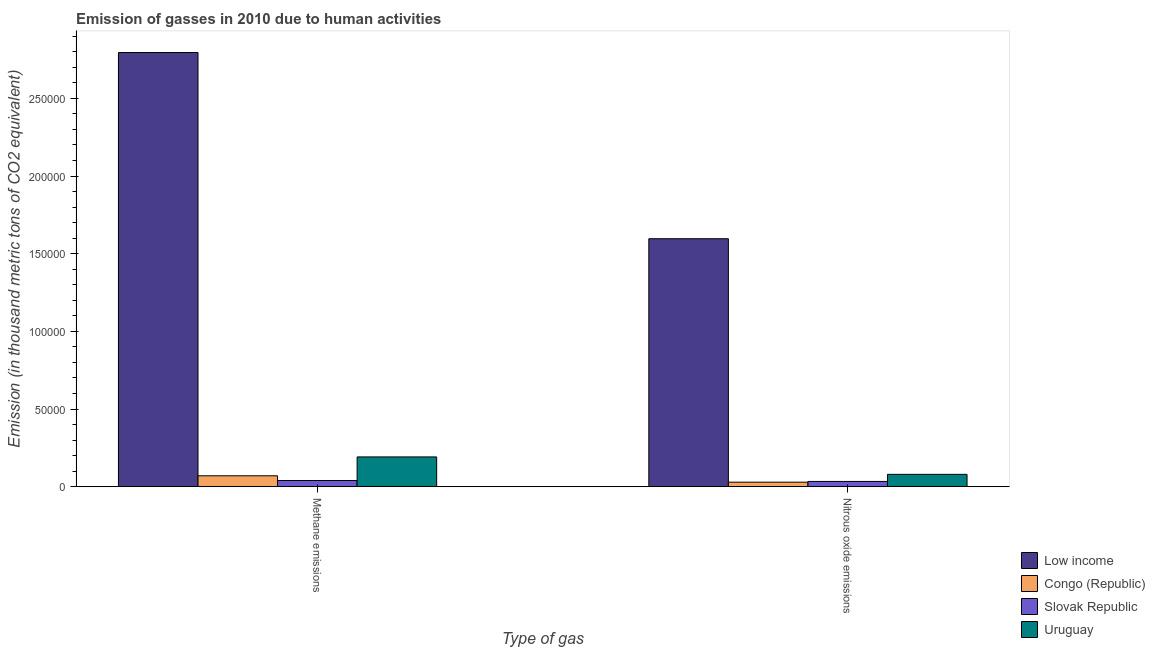How many different coloured bars are there?
Offer a terse response. 4. How many groups of bars are there?
Make the answer very short. 2. Are the number of bars per tick equal to the number of legend labels?
Your response must be concise. Yes. Are the number of bars on each tick of the X-axis equal?
Ensure brevity in your answer.  Yes. How many bars are there on the 2nd tick from the right?
Your answer should be very brief. 4. What is the label of the 2nd group of bars from the left?
Give a very brief answer. Nitrous oxide emissions. What is the amount of nitrous oxide emissions in Slovak Republic?
Offer a terse response. 3380.2. Across all countries, what is the maximum amount of methane emissions?
Your answer should be very brief. 2.79e+05. Across all countries, what is the minimum amount of nitrous oxide emissions?
Ensure brevity in your answer.  2899.8. In which country was the amount of methane emissions maximum?
Give a very brief answer. Low income. In which country was the amount of nitrous oxide emissions minimum?
Ensure brevity in your answer.  Congo (Republic). What is the total amount of nitrous oxide emissions in the graph?
Provide a short and direct response. 1.74e+05. What is the difference between the amount of methane emissions in Congo (Republic) and that in Uruguay?
Provide a short and direct response. -1.21e+04. What is the difference between the amount of nitrous oxide emissions in Uruguay and the amount of methane emissions in Slovak Republic?
Provide a succinct answer. 3961.8. What is the average amount of methane emissions per country?
Offer a terse response. 7.74e+04. What is the difference between the amount of nitrous oxide emissions and amount of methane emissions in Congo (Republic)?
Make the answer very short. -4116.2. In how many countries, is the amount of nitrous oxide emissions greater than 140000 thousand metric tons?
Keep it short and to the point. 1. What is the ratio of the amount of nitrous oxide emissions in Low income to that in Slovak Republic?
Your answer should be very brief. 47.22. What does the 3rd bar from the left in Nitrous oxide emissions represents?
Give a very brief answer. Slovak Republic. What does the 2nd bar from the right in Nitrous oxide emissions represents?
Offer a very short reply. Slovak Republic. How many bars are there?
Provide a short and direct response. 8. Are all the bars in the graph horizontal?
Ensure brevity in your answer.  No. Are the values on the major ticks of Y-axis written in scientific E-notation?
Offer a terse response. No. Does the graph contain any zero values?
Your response must be concise. No. Does the graph contain grids?
Make the answer very short. No. Where does the legend appear in the graph?
Make the answer very short. Bottom right. How many legend labels are there?
Provide a short and direct response. 4. What is the title of the graph?
Give a very brief answer. Emission of gasses in 2010 due to human activities. What is the label or title of the X-axis?
Ensure brevity in your answer.  Type of gas. What is the label or title of the Y-axis?
Offer a very short reply. Emission (in thousand metric tons of CO2 equivalent). What is the Emission (in thousand metric tons of CO2 equivalent) of Low income in Methane emissions?
Offer a very short reply. 2.79e+05. What is the Emission (in thousand metric tons of CO2 equivalent) in Congo (Republic) in Methane emissions?
Ensure brevity in your answer.  7016. What is the Emission (in thousand metric tons of CO2 equivalent) of Slovak Republic in Methane emissions?
Make the answer very short. 3984.7. What is the Emission (in thousand metric tons of CO2 equivalent) of Uruguay in Methane emissions?
Offer a terse response. 1.92e+04. What is the Emission (in thousand metric tons of CO2 equivalent) in Low income in Nitrous oxide emissions?
Make the answer very short. 1.60e+05. What is the Emission (in thousand metric tons of CO2 equivalent) of Congo (Republic) in Nitrous oxide emissions?
Your response must be concise. 2899.8. What is the Emission (in thousand metric tons of CO2 equivalent) in Slovak Republic in Nitrous oxide emissions?
Give a very brief answer. 3380.2. What is the Emission (in thousand metric tons of CO2 equivalent) in Uruguay in Nitrous oxide emissions?
Make the answer very short. 7946.5. Across all Type of gas, what is the maximum Emission (in thousand metric tons of CO2 equivalent) in Low income?
Offer a terse response. 2.79e+05. Across all Type of gas, what is the maximum Emission (in thousand metric tons of CO2 equivalent) of Congo (Republic)?
Offer a terse response. 7016. Across all Type of gas, what is the maximum Emission (in thousand metric tons of CO2 equivalent) in Slovak Republic?
Give a very brief answer. 3984.7. Across all Type of gas, what is the maximum Emission (in thousand metric tons of CO2 equivalent) in Uruguay?
Make the answer very short. 1.92e+04. Across all Type of gas, what is the minimum Emission (in thousand metric tons of CO2 equivalent) of Low income?
Keep it short and to the point. 1.60e+05. Across all Type of gas, what is the minimum Emission (in thousand metric tons of CO2 equivalent) of Congo (Republic)?
Make the answer very short. 2899.8. Across all Type of gas, what is the minimum Emission (in thousand metric tons of CO2 equivalent) of Slovak Republic?
Your answer should be very brief. 3380.2. Across all Type of gas, what is the minimum Emission (in thousand metric tons of CO2 equivalent) in Uruguay?
Your answer should be compact. 7946.5. What is the total Emission (in thousand metric tons of CO2 equivalent) in Low income in the graph?
Your answer should be compact. 4.39e+05. What is the total Emission (in thousand metric tons of CO2 equivalent) of Congo (Republic) in the graph?
Offer a terse response. 9915.8. What is the total Emission (in thousand metric tons of CO2 equivalent) in Slovak Republic in the graph?
Provide a succinct answer. 7364.9. What is the total Emission (in thousand metric tons of CO2 equivalent) in Uruguay in the graph?
Provide a short and direct response. 2.71e+04. What is the difference between the Emission (in thousand metric tons of CO2 equivalent) of Low income in Methane emissions and that in Nitrous oxide emissions?
Make the answer very short. 1.20e+05. What is the difference between the Emission (in thousand metric tons of CO2 equivalent) in Congo (Republic) in Methane emissions and that in Nitrous oxide emissions?
Offer a terse response. 4116.2. What is the difference between the Emission (in thousand metric tons of CO2 equivalent) in Slovak Republic in Methane emissions and that in Nitrous oxide emissions?
Your answer should be very brief. 604.5. What is the difference between the Emission (in thousand metric tons of CO2 equivalent) of Uruguay in Methane emissions and that in Nitrous oxide emissions?
Offer a very short reply. 1.12e+04. What is the difference between the Emission (in thousand metric tons of CO2 equivalent) of Low income in Methane emissions and the Emission (in thousand metric tons of CO2 equivalent) of Congo (Republic) in Nitrous oxide emissions?
Give a very brief answer. 2.77e+05. What is the difference between the Emission (in thousand metric tons of CO2 equivalent) of Low income in Methane emissions and the Emission (in thousand metric tons of CO2 equivalent) of Slovak Republic in Nitrous oxide emissions?
Offer a terse response. 2.76e+05. What is the difference between the Emission (in thousand metric tons of CO2 equivalent) of Low income in Methane emissions and the Emission (in thousand metric tons of CO2 equivalent) of Uruguay in Nitrous oxide emissions?
Offer a terse response. 2.72e+05. What is the difference between the Emission (in thousand metric tons of CO2 equivalent) in Congo (Republic) in Methane emissions and the Emission (in thousand metric tons of CO2 equivalent) in Slovak Republic in Nitrous oxide emissions?
Provide a succinct answer. 3635.8. What is the difference between the Emission (in thousand metric tons of CO2 equivalent) in Congo (Republic) in Methane emissions and the Emission (in thousand metric tons of CO2 equivalent) in Uruguay in Nitrous oxide emissions?
Your answer should be compact. -930.5. What is the difference between the Emission (in thousand metric tons of CO2 equivalent) in Slovak Republic in Methane emissions and the Emission (in thousand metric tons of CO2 equivalent) in Uruguay in Nitrous oxide emissions?
Ensure brevity in your answer.  -3961.8. What is the average Emission (in thousand metric tons of CO2 equivalent) of Low income per Type of gas?
Your response must be concise. 2.20e+05. What is the average Emission (in thousand metric tons of CO2 equivalent) of Congo (Republic) per Type of gas?
Make the answer very short. 4957.9. What is the average Emission (in thousand metric tons of CO2 equivalent) in Slovak Republic per Type of gas?
Make the answer very short. 3682.45. What is the average Emission (in thousand metric tons of CO2 equivalent) in Uruguay per Type of gas?
Offer a very short reply. 1.36e+04. What is the difference between the Emission (in thousand metric tons of CO2 equivalent) in Low income and Emission (in thousand metric tons of CO2 equivalent) in Congo (Republic) in Methane emissions?
Your answer should be very brief. 2.72e+05. What is the difference between the Emission (in thousand metric tons of CO2 equivalent) of Low income and Emission (in thousand metric tons of CO2 equivalent) of Slovak Republic in Methane emissions?
Your answer should be very brief. 2.75e+05. What is the difference between the Emission (in thousand metric tons of CO2 equivalent) of Low income and Emission (in thousand metric tons of CO2 equivalent) of Uruguay in Methane emissions?
Provide a short and direct response. 2.60e+05. What is the difference between the Emission (in thousand metric tons of CO2 equivalent) in Congo (Republic) and Emission (in thousand metric tons of CO2 equivalent) in Slovak Republic in Methane emissions?
Make the answer very short. 3031.3. What is the difference between the Emission (in thousand metric tons of CO2 equivalent) in Congo (Republic) and Emission (in thousand metric tons of CO2 equivalent) in Uruguay in Methane emissions?
Ensure brevity in your answer.  -1.21e+04. What is the difference between the Emission (in thousand metric tons of CO2 equivalent) in Slovak Republic and Emission (in thousand metric tons of CO2 equivalent) in Uruguay in Methane emissions?
Offer a terse response. -1.52e+04. What is the difference between the Emission (in thousand metric tons of CO2 equivalent) in Low income and Emission (in thousand metric tons of CO2 equivalent) in Congo (Republic) in Nitrous oxide emissions?
Provide a succinct answer. 1.57e+05. What is the difference between the Emission (in thousand metric tons of CO2 equivalent) of Low income and Emission (in thousand metric tons of CO2 equivalent) of Slovak Republic in Nitrous oxide emissions?
Make the answer very short. 1.56e+05. What is the difference between the Emission (in thousand metric tons of CO2 equivalent) in Low income and Emission (in thousand metric tons of CO2 equivalent) in Uruguay in Nitrous oxide emissions?
Make the answer very short. 1.52e+05. What is the difference between the Emission (in thousand metric tons of CO2 equivalent) in Congo (Republic) and Emission (in thousand metric tons of CO2 equivalent) in Slovak Republic in Nitrous oxide emissions?
Give a very brief answer. -480.4. What is the difference between the Emission (in thousand metric tons of CO2 equivalent) in Congo (Republic) and Emission (in thousand metric tons of CO2 equivalent) in Uruguay in Nitrous oxide emissions?
Provide a short and direct response. -5046.7. What is the difference between the Emission (in thousand metric tons of CO2 equivalent) of Slovak Republic and Emission (in thousand metric tons of CO2 equivalent) of Uruguay in Nitrous oxide emissions?
Provide a short and direct response. -4566.3. What is the ratio of the Emission (in thousand metric tons of CO2 equivalent) in Low income in Methane emissions to that in Nitrous oxide emissions?
Ensure brevity in your answer.  1.75. What is the ratio of the Emission (in thousand metric tons of CO2 equivalent) of Congo (Republic) in Methane emissions to that in Nitrous oxide emissions?
Offer a terse response. 2.42. What is the ratio of the Emission (in thousand metric tons of CO2 equivalent) in Slovak Republic in Methane emissions to that in Nitrous oxide emissions?
Provide a succinct answer. 1.18. What is the ratio of the Emission (in thousand metric tons of CO2 equivalent) in Uruguay in Methane emissions to that in Nitrous oxide emissions?
Offer a very short reply. 2.41. What is the difference between the highest and the second highest Emission (in thousand metric tons of CO2 equivalent) of Low income?
Ensure brevity in your answer.  1.20e+05. What is the difference between the highest and the second highest Emission (in thousand metric tons of CO2 equivalent) in Congo (Republic)?
Give a very brief answer. 4116.2. What is the difference between the highest and the second highest Emission (in thousand metric tons of CO2 equivalent) in Slovak Republic?
Your answer should be very brief. 604.5. What is the difference between the highest and the second highest Emission (in thousand metric tons of CO2 equivalent) in Uruguay?
Provide a succinct answer. 1.12e+04. What is the difference between the highest and the lowest Emission (in thousand metric tons of CO2 equivalent) in Low income?
Offer a terse response. 1.20e+05. What is the difference between the highest and the lowest Emission (in thousand metric tons of CO2 equivalent) of Congo (Republic)?
Provide a short and direct response. 4116.2. What is the difference between the highest and the lowest Emission (in thousand metric tons of CO2 equivalent) of Slovak Republic?
Provide a short and direct response. 604.5. What is the difference between the highest and the lowest Emission (in thousand metric tons of CO2 equivalent) in Uruguay?
Offer a terse response. 1.12e+04. 